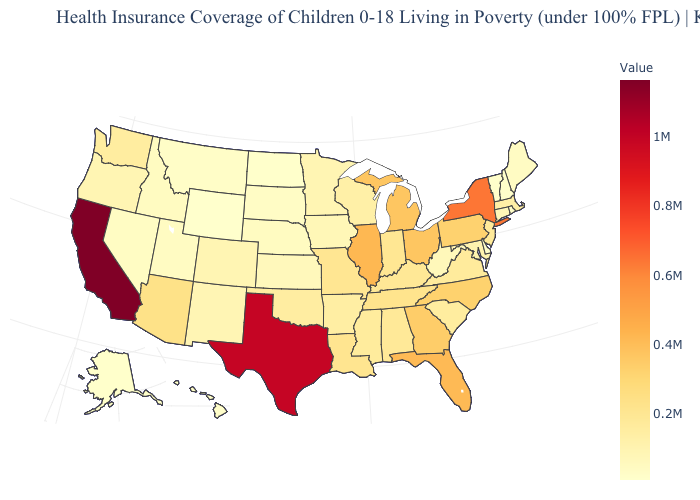Does Idaho have the lowest value in the West?
Keep it brief. No. Among the states that border Washington , which have the highest value?
Concise answer only. Oregon. Which states hav the highest value in the South?
Be succinct. Texas. Which states have the lowest value in the USA?
Give a very brief answer. Wyoming. Which states hav the highest value in the MidWest?
Give a very brief answer. Illinois. 